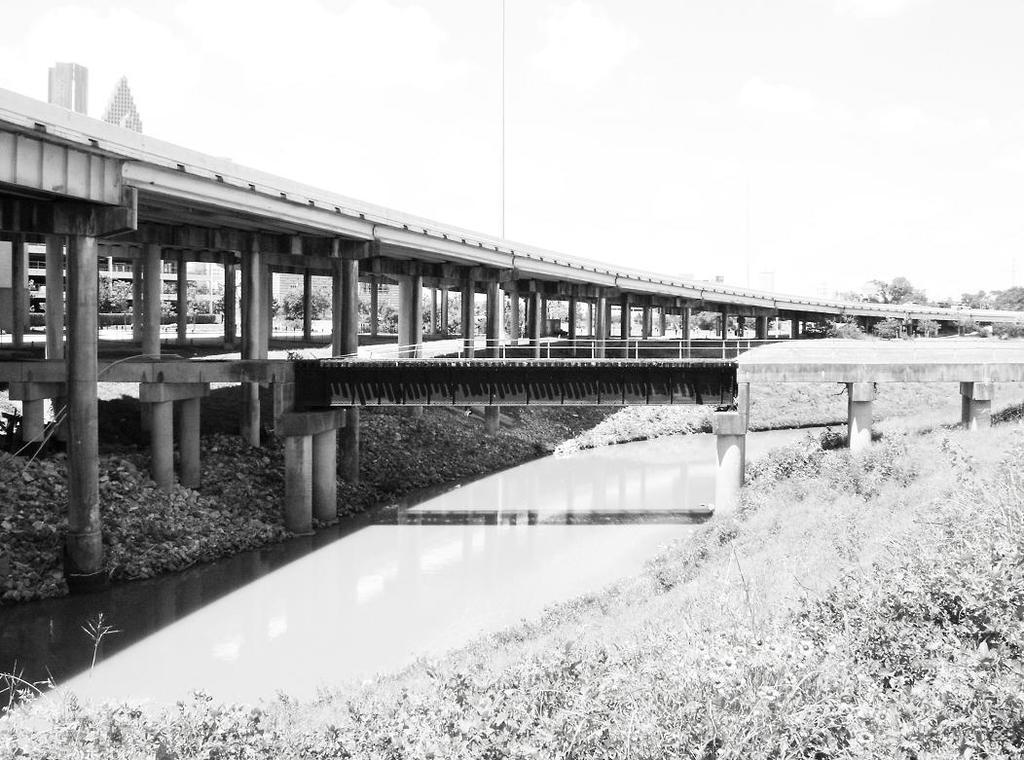What structure is the main subject of the image? There is a bridge in the image. What can be seen at the bottom of the image? There is water at the bottom of the image. What type of vegetation is on the right side of the image? There are small plants on the right side of the image. What is visible at the top of the image? The sky is visible at the top of the image. What can be seen in the background of the image? There is a building and trees in the background of the image. What type of vegetable is growing on the bridge in the image? There are no vegetables growing on the bridge in the image; it is a structure for crossing water. 